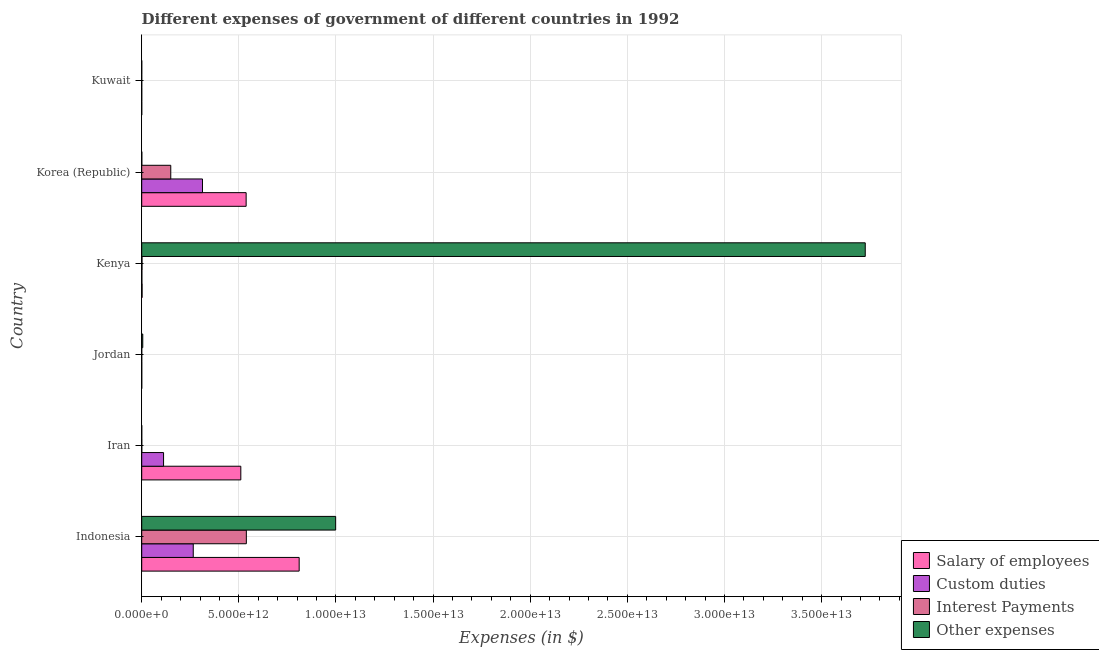How many groups of bars are there?
Provide a short and direct response. 6. Are the number of bars on each tick of the Y-axis equal?
Your answer should be very brief. Yes. How many bars are there on the 5th tick from the top?
Your answer should be very brief. 4. How many bars are there on the 5th tick from the bottom?
Your response must be concise. 4. What is the label of the 1st group of bars from the top?
Ensure brevity in your answer.  Kuwait. What is the amount spent on other expenses in Korea (Republic)?
Your response must be concise. 4.71e+09. Across all countries, what is the maximum amount spent on custom duties?
Ensure brevity in your answer.  3.13e+12. Across all countries, what is the minimum amount spent on interest payments?
Provide a short and direct response. 5.83e+07. In which country was the amount spent on interest payments maximum?
Keep it short and to the point. Indonesia. In which country was the amount spent on other expenses minimum?
Give a very brief answer. Kuwait. What is the total amount spent on interest payments in the graph?
Offer a terse response. 6.90e+12. What is the difference between the amount spent on other expenses in Jordan and that in Kenya?
Keep it short and to the point. -3.72e+13. What is the difference between the amount spent on interest payments in Kenya and the amount spent on salary of employees in Kuwait?
Provide a short and direct response. 1.41e+1. What is the average amount spent on custom duties per country?
Provide a short and direct response. 1.15e+12. What is the difference between the amount spent on interest payments and amount spent on other expenses in Kuwait?
Offer a very short reply. -6.51e+08. What is the ratio of the amount spent on salary of employees in Jordan to that in Kenya?
Keep it short and to the point. 0.03. Is the amount spent on salary of employees in Iran less than that in Kuwait?
Offer a terse response. No. Is the difference between the amount spent on interest payments in Iran and Kenya greater than the difference between the amount spent on salary of employees in Iran and Kenya?
Provide a short and direct response. No. What is the difference between the highest and the second highest amount spent on custom duties?
Ensure brevity in your answer.  4.76e+11. What is the difference between the highest and the lowest amount spent on interest payments?
Ensure brevity in your answer.  5.39e+12. In how many countries, is the amount spent on other expenses greater than the average amount spent on other expenses taken over all countries?
Offer a very short reply. 2. Is the sum of the amount spent on interest payments in Iran and Kenya greater than the maximum amount spent on custom duties across all countries?
Make the answer very short. No. What does the 1st bar from the top in Iran represents?
Offer a very short reply. Other expenses. What does the 3rd bar from the bottom in Jordan represents?
Keep it short and to the point. Interest Payments. Is it the case that in every country, the sum of the amount spent on salary of employees and amount spent on custom duties is greater than the amount spent on interest payments?
Ensure brevity in your answer.  Yes. How many bars are there?
Your answer should be very brief. 24. How many countries are there in the graph?
Provide a short and direct response. 6. What is the difference between two consecutive major ticks on the X-axis?
Your answer should be very brief. 5.00e+12. Are the values on the major ticks of X-axis written in scientific E-notation?
Keep it short and to the point. Yes. Does the graph contain grids?
Make the answer very short. Yes. How many legend labels are there?
Offer a terse response. 4. What is the title of the graph?
Offer a very short reply. Different expenses of government of different countries in 1992. Does "Luxembourg" appear as one of the legend labels in the graph?
Offer a very short reply. No. What is the label or title of the X-axis?
Provide a succinct answer. Expenses (in $). What is the label or title of the Y-axis?
Your answer should be very brief. Country. What is the Expenses (in $) of Salary of employees in Indonesia?
Offer a very short reply. 8.10e+12. What is the Expenses (in $) of Custom duties in Indonesia?
Offer a terse response. 2.65e+12. What is the Expenses (in $) in Interest Payments in Indonesia?
Make the answer very short. 5.39e+12. What is the Expenses (in $) in Other expenses in Indonesia?
Provide a succinct answer. 9.98e+12. What is the Expenses (in $) in Salary of employees in Iran?
Give a very brief answer. 5.10e+12. What is the Expenses (in $) of Custom duties in Iran?
Ensure brevity in your answer.  1.12e+12. What is the Expenses (in $) in Interest Payments in Iran?
Provide a succinct answer. 3.00e+09. What is the Expenses (in $) of Other expenses in Iran?
Offer a very short reply. 8.91e+08. What is the Expenses (in $) in Salary of employees in Jordan?
Your answer should be compact. 5.57e+08. What is the Expenses (in $) in Custom duties in Jordan?
Make the answer very short. 3.89e+08. What is the Expenses (in $) of Interest Payments in Jordan?
Ensure brevity in your answer.  1.56e+08. What is the Expenses (in $) of Other expenses in Jordan?
Your answer should be very brief. 5.39e+1. What is the Expenses (in $) in Salary of employees in Kenya?
Provide a short and direct response. 1.91e+1. What is the Expenses (in $) of Custom duties in Kenya?
Ensure brevity in your answer.  7.74e+09. What is the Expenses (in $) in Interest Payments in Kenya?
Offer a very short reply. 1.49e+1. What is the Expenses (in $) of Other expenses in Kenya?
Offer a very short reply. 3.72e+13. What is the Expenses (in $) in Salary of employees in Korea (Republic)?
Ensure brevity in your answer.  5.38e+12. What is the Expenses (in $) of Custom duties in Korea (Republic)?
Provide a short and direct response. 3.13e+12. What is the Expenses (in $) of Interest Payments in Korea (Republic)?
Offer a terse response. 1.50e+12. What is the Expenses (in $) of Other expenses in Korea (Republic)?
Keep it short and to the point. 4.71e+09. What is the Expenses (in $) in Salary of employees in Kuwait?
Make the answer very short. 8.70e+08. What is the Expenses (in $) of Custom duties in Kuwait?
Offer a very short reply. 5.48e+08. What is the Expenses (in $) of Interest Payments in Kuwait?
Offer a terse response. 5.83e+07. What is the Expenses (in $) in Other expenses in Kuwait?
Your response must be concise. 7.09e+08. Across all countries, what is the maximum Expenses (in $) of Salary of employees?
Offer a very short reply. 8.10e+12. Across all countries, what is the maximum Expenses (in $) of Custom duties?
Offer a very short reply. 3.13e+12. Across all countries, what is the maximum Expenses (in $) of Interest Payments?
Provide a short and direct response. 5.39e+12. Across all countries, what is the maximum Expenses (in $) of Other expenses?
Provide a succinct answer. 3.72e+13. Across all countries, what is the minimum Expenses (in $) in Salary of employees?
Offer a terse response. 5.57e+08. Across all countries, what is the minimum Expenses (in $) of Custom duties?
Give a very brief answer. 3.89e+08. Across all countries, what is the minimum Expenses (in $) of Interest Payments?
Your answer should be compact. 5.83e+07. Across all countries, what is the minimum Expenses (in $) in Other expenses?
Keep it short and to the point. 7.09e+08. What is the total Expenses (in $) of Salary of employees in the graph?
Offer a very short reply. 1.86e+13. What is the total Expenses (in $) in Custom duties in the graph?
Make the answer very short. 6.91e+12. What is the total Expenses (in $) in Interest Payments in the graph?
Your response must be concise. 6.90e+12. What is the total Expenses (in $) in Other expenses in the graph?
Provide a succinct answer. 4.73e+13. What is the difference between the Expenses (in $) in Salary of employees in Indonesia and that in Iran?
Make the answer very short. 3.00e+12. What is the difference between the Expenses (in $) in Custom duties in Indonesia and that in Iran?
Give a very brief answer. 1.53e+12. What is the difference between the Expenses (in $) of Interest Payments in Indonesia and that in Iran?
Give a very brief answer. 5.38e+12. What is the difference between the Expenses (in $) of Other expenses in Indonesia and that in Iran?
Offer a terse response. 9.98e+12. What is the difference between the Expenses (in $) in Salary of employees in Indonesia and that in Jordan?
Make the answer very short. 8.10e+12. What is the difference between the Expenses (in $) in Custom duties in Indonesia and that in Jordan?
Your response must be concise. 2.65e+12. What is the difference between the Expenses (in $) of Interest Payments in Indonesia and that in Jordan?
Provide a short and direct response. 5.39e+12. What is the difference between the Expenses (in $) of Other expenses in Indonesia and that in Jordan?
Your answer should be very brief. 9.93e+12. What is the difference between the Expenses (in $) in Salary of employees in Indonesia and that in Kenya?
Your response must be concise. 8.09e+12. What is the difference between the Expenses (in $) in Custom duties in Indonesia and that in Kenya?
Give a very brief answer. 2.64e+12. What is the difference between the Expenses (in $) in Interest Payments in Indonesia and that in Kenya?
Provide a succinct answer. 5.37e+12. What is the difference between the Expenses (in $) in Other expenses in Indonesia and that in Kenya?
Provide a succinct answer. -2.73e+13. What is the difference between the Expenses (in $) of Salary of employees in Indonesia and that in Korea (Republic)?
Give a very brief answer. 2.73e+12. What is the difference between the Expenses (in $) of Custom duties in Indonesia and that in Korea (Republic)?
Offer a terse response. -4.76e+11. What is the difference between the Expenses (in $) in Interest Payments in Indonesia and that in Korea (Republic)?
Provide a succinct answer. 3.89e+12. What is the difference between the Expenses (in $) of Other expenses in Indonesia and that in Korea (Republic)?
Provide a succinct answer. 9.98e+12. What is the difference between the Expenses (in $) in Salary of employees in Indonesia and that in Kuwait?
Offer a terse response. 8.10e+12. What is the difference between the Expenses (in $) in Custom duties in Indonesia and that in Kuwait?
Offer a terse response. 2.65e+12. What is the difference between the Expenses (in $) in Interest Payments in Indonesia and that in Kuwait?
Offer a terse response. 5.39e+12. What is the difference between the Expenses (in $) in Other expenses in Indonesia and that in Kuwait?
Your answer should be very brief. 9.98e+12. What is the difference between the Expenses (in $) in Salary of employees in Iran and that in Jordan?
Your answer should be compact. 5.10e+12. What is the difference between the Expenses (in $) in Custom duties in Iran and that in Jordan?
Offer a terse response. 1.12e+12. What is the difference between the Expenses (in $) in Interest Payments in Iran and that in Jordan?
Provide a short and direct response. 2.84e+09. What is the difference between the Expenses (in $) in Other expenses in Iran and that in Jordan?
Offer a terse response. -5.30e+1. What is the difference between the Expenses (in $) of Salary of employees in Iran and that in Kenya?
Your response must be concise. 5.08e+12. What is the difference between the Expenses (in $) of Custom duties in Iran and that in Kenya?
Give a very brief answer. 1.12e+12. What is the difference between the Expenses (in $) in Interest Payments in Iran and that in Kenya?
Make the answer very short. -1.19e+1. What is the difference between the Expenses (in $) in Other expenses in Iran and that in Kenya?
Provide a succinct answer. -3.72e+13. What is the difference between the Expenses (in $) in Salary of employees in Iran and that in Korea (Republic)?
Give a very brief answer. -2.74e+11. What is the difference between the Expenses (in $) of Custom duties in Iran and that in Korea (Republic)?
Your answer should be compact. -2.00e+12. What is the difference between the Expenses (in $) in Interest Payments in Iran and that in Korea (Republic)?
Ensure brevity in your answer.  -1.49e+12. What is the difference between the Expenses (in $) of Other expenses in Iran and that in Korea (Republic)?
Ensure brevity in your answer.  -3.82e+09. What is the difference between the Expenses (in $) in Salary of employees in Iran and that in Kuwait?
Ensure brevity in your answer.  5.10e+12. What is the difference between the Expenses (in $) of Custom duties in Iran and that in Kuwait?
Make the answer very short. 1.12e+12. What is the difference between the Expenses (in $) in Interest Payments in Iran and that in Kuwait?
Keep it short and to the point. 2.94e+09. What is the difference between the Expenses (in $) in Other expenses in Iran and that in Kuwait?
Provide a short and direct response. 1.82e+08. What is the difference between the Expenses (in $) in Salary of employees in Jordan and that in Kenya?
Make the answer very short. -1.86e+1. What is the difference between the Expenses (in $) of Custom duties in Jordan and that in Kenya?
Ensure brevity in your answer.  -7.35e+09. What is the difference between the Expenses (in $) in Interest Payments in Jordan and that in Kenya?
Provide a succinct answer. -1.48e+1. What is the difference between the Expenses (in $) in Other expenses in Jordan and that in Kenya?
Make the answer very short. -3.72e+13. What is the difference between the Expenses (in $) in Salary of employees in Jordan and that in Korea (Republic)?
Ensure brevity in your answer.  -5.37e+12. What is the difference between the Expenses (in $) in Custom duties in Jordan and that in Korea (Republic)?
Your answer should be very brief. -3.13e+12. What is the difference between the Expenses (in $) of Interest Payments in Jordan and that in Korea (Republic)?
Your response must be concise. -1.49e+12. What is the difference between the Expenses (in $) of Other expenses in Jordan and that in Korea (Republic)?
Provide a short and direct response. 4.92e+1. What is the difference between the Expenses (in $) in Salary of employees in Jordan and that in Kuwait?
Your answer should be compact. -3.13e+08. What is the difference between the Expenses (in $) of Custom duties in Jordan and that in Kuwait?
Offer a terse response. -1.59e+08. What is the difference between the Expenses (in $) of Interest Payments in Jordan and that in Kuwait?
Give a very brief answer. 9.75e+07. What is the difference between the Expenses (in $) of Other expenses in Jordan and that in Kuwait?
Your answer should be very brief. 5.32e+1. What is the difference between the Expenses (in $) in Salary of employees in Kenya and that in Korea (Republic)?
Your response must be concise. -5.36e+12. What is the difference between the Expenses (in $) of Custom duties in Kenya and that in Korea (Republic)?
Keep it short and to the point. -3.12e+12. What is the difference between the Expenses (in $) of Interest Payments in Kenya and that in Korea (Republic)?
Ensure brevity in your answer.  -1.48e+12. What is the difference between the Expenses (in $) of Other expenses in Kenya and that in Korea (Republic)?
Your answer should be compact. 3.72e+13. What is the difference between the Expenses (in $) of Salary of employees in Kenya and that in Kuwait?
Provide a succinct answer. 1.82e+1. What is the difference between the Expenses (in $) in Custom duties in Kenya and that in Kuwait?
Ensure brevity in your answer.  7.19e+09. What is the difference between the Expenses (in $) in Interest Payments in Kenya and that in Kuwait?
Ensure brevity in your answer.  1.49e+1. What is the difference between the Expenses (in $) in Other expenses in Kenya and that in Kuwait?
Provide a succinct answer. 3.72e+13. What is the difference between the Expenses (in $) of Salary of employees in Korea (Republic) and that in Kuwait?
Your answer should be very brief. 5.37e+12. What is the difference between the Expenses (in $) of Custom duties in Korea (Republic) and that in Kuwait?
Offer a very short reply. 3.13e+12. What is the difference between the Expenses (in $) in Interest Payments in Korea (Republic) and that in Kuwait?
Keep it short and to the point. 1.49e+12. What is the difference between the Expenses (in $) of Other expenses in Korea (Republic) and that in Kuwait?
Ensure brevity in your answer.  4.00e+09. What is the difference between the Expenses (in $) of Salary of employees in Indonesia and the Expenses (in $) of Custom duties in Iran?
Ensure brevity in your answer.  6.98e+12. What is the difference between the Expenses (in $) in Salary of employees in Indonesia and the Expenses (in $) in Interest Payments in Iran?
Your answer should be very brief. 8.10e+12. What is the difference between the Expenses (in $) of Salary of employees in Indonesia and the Expenses (in $) of Other expenses in Iran?
Give a very brief answer. 8.10e+12. What is the difference between the Expenses (in $) of Custom duties in Indonesia and the Expenses (in $) of Interest Payments in Iran?
Your answer should be compact. 2.65e+12. What is the difference between the Expenses (in $) in Custom duties in Indonesia and the Expenses (in $) in Other expenses in Iran?
Your answer should be very brief. 2.65e+12. What is the difference between the Expenses (in $) of Interest Payments in Indonesia and the Expenses (in $) of Other expenses in Iran?
Keep it short and to the point. 5.38e+12. What is the difference between the Expenses (in $) in Salary of employees in Indonesia and the Expenses (in $) in Custom duties in Jordan?
Ensure brevity in your answer.  8.10e+12. What is the difference between the Expenses (in $) in Salary of employees in Indonesia and the Expenses (in $) in Interest Payments in Jordan?
Give a very brief answer. 8.10e+12. What is the difference between the Expenses (in $) of Salary of employees in Indonesia and the Expenses (in $) of Other expenses in Jordan?
Keep it short and to the point. 8.05e+12. What is the difference between the Expenses (in $) in Custom duties in Indonesia and the Expenses (in $) in Interest Payments in Jordan?
Keep it short and to the point. 2.65e+12. What is the difference between the Expenses (in $) in Custom duties in Indonesia and the Expenses (in $) in Other expenses in Jordan?
Make the answer very short. 2.60e+12. What is the difference between the Expenses (in $) in Interest Payments in Indonesia and the Expenses (in $) in Other expenses in Jordan?
Keep it short and to the point. 5.33e+12. What is the difference between the Expenses (in $) of Salary of employees in Indonesia and the Expenses (in $) of Custom duties in Kenya?
Your response must be concise. 8.10e+12. What is the difference between the Expenses (in $) of Salary of employees in Indonesia and the Expenses (in $) of Interest Payments in Kenya?
Keep it short and to the point. 8.09e+12. What is the difference between the Expenses (in $) in Salary of employees in Indonesia and the Expenses (in $) in Other expenses in Kenya?
Give a very brief answer. -2.91e+13. What is the difference between the Expenses (in $) of Custom duties in Indonesia and the Expenses (in $) of Interest Payments in Kenya?
Your answer should be compact. 2.64e+12. What is the difference between the Expenses (in $) of Custom duties in Indonesia and the Expenses (in $) of Other expenses in Kenya?
Give a very brief answer. -3.46e+13. What is the difference between the Expenses (in $) in Interest Payments in Indonesia and the Expenses (in $) in Other expenses in Kenya?
Keep it short and to the point. -3.19e+13. What is the difference between the Expenses (in $) in Salary of employees in Indonesia and the Expenses (in $) in Custom duties in Korea (Republic)?
Your response must be concise. 4.98e+12. What is the difference between the Expenses (in $) of Salary of employees in Indonesia and the Expenses (in $) of Interest Payments in Korea (Republic)?
Make the answer very short. 6.61e+12. What is the difference between the Expenses (in $) of Salary of employees in Indonesia and the Expenses (in $) of Other expenses in Korea (Republic)?
Give a very brief answer. 8.10e+12. What is the difference between the Expenses (in $) in Custom duties in Indonesia and the Expenses (in $) in Interest Payments in Korea (Republic)?
Your answer should be very brief. 1.16e+12. What is the difference between the Expenses (in $) of Custom duties in Indonesia and the Expenses (in $) of Other expenses in Korea (Republic)?
Give a very brief answer. 2.65e+12. What is the difference between the Expenses (in $) in Interest Payments in Indonesia and the Expenses (in $) in Other expenses in Korea (Republic)?
Offer a very short reply. 5.38e+12. What is the difference between the Expenses (in $) of Salary of employees in Indonesia and the Expenses (in $) of Custom duties in Kuwait?
Give a very brief answer. 8.10e+12. What is the difference between the Expenses (in $) in Salary of employees in Indonesia and the Expenses (in $) in Interest Payments in Kuwait?
Offer a very short reply. 8.10e+12. What is the difference between the Expenses (in $) in Salary of employees in Indonesia and the Expenses (in $) in Other expenses in Kuwait?
Your answer should be very brief. 8.10e+12. What is the difference between the Expenses (in $) of Custom duties in Indonesia and the Expenses (in $) of Interest Payments in Kuwait?
Keep it short and to the point. 2.65e+12. What is the difference between the Expenses (in $) of Custom duties in Indonesia and the Expenses (in $) of Other expenses in Kuwait?
Ensure brevity in your answer.  2.65e+12. What is the difference between the Expenses (in $) in Interest Payments in Indonesia and the Expenses (in $) in Other expenses in Kuwait?
Your response must be concise. 5.38e+12. What is the difference between the Expenses (in $) in Salary of employees in Iran and the Expenses (in $) in Custom duties in Jordan?
Provide a succinct answer. 5.10e+12. What is the difference between the Expenses (in $) of Salary of employees in Iran and the Expenses (in $) of Interest Payments in Jordan?
Make the answer very short. 5.10e+12. What is the difference between the Expenses (in $) of Salary of employees in Iran and the Expenses (in $) of Other expenses in Jordan?
Your response must be concise. 5.05e+12. What is the difference between the Expenses (in $) of Custom duties in Iran and the Expenses (in $) of Interest Payments in Jordan?
Give a very brief answer. 1.12e+12. What is the difference between the Expenses (in $) in Custom duties in Iran and the Expenses (in $) in Other expenses in Jordan?
Give a very brief answer. 1.07e+12. What is the difference between the Expenses (in $) of Interest Payments in Iran and the Expenses (in $) of Other expenses in Jordan?
Provide a short and direct response. -5.09e+1. What is the difference between the Expenses (in $) in Salary of employees in Iran and the Expenses (in $) in Custom duties in Kenya?
Make the answer very short. 5.09e+12. What is the difference between the Expenses (in $) in Salary of employees in Iran and the Expenses (in $) in Interest Payments in Kenya?
Ensure brevity in your answer.  5.09e+12. What is the difference between the Expenses (in $) in Salary of employees in Iran and the Expenses (in $) in Other expenses in Kenya?
Your answer should be compact. -3.21e+13. What is the difference between the Expenses (in $) in Custom duties in Iran and the Expenses (in $) in Interest Payments in Kenya?
Your answer should be compact. 1.11e+12. What is the difference between the Expenses (in $) in Custom duties in Iran and the Expenses (in $) in Other expenses in Kenya?
Your response must be concise. -3.61e+13. What is the difference between the Expenses (in $) of Interest Payments in Iran and the Expenses (in $) of Other expenses in Kenya?
Offer a terse response. -3.72e+13. What is the difference between the Expenses (in $) in Salary of employees in Iran and the Expenses (in $) in Custom duties in Korea (Republic)?
Provide a succinct answer. 1.97e+12. What is the difference between the Expenses (in $) of Salary of employees in Iran and the Expenses (in $) of Interest Payments in Korea (Republic)?
Offer a terse response. 3.61e+12. What is the difference between the Expenses (in $) of Salary of employees in Iran and the Expenses (in $) of Other expenses in Korea (Republic)?
Provide a succinct answer. 5.10e+12. What is the difference between the Expenses (in $) in Custom duties in Iran and the Expenses (in $) in Interest Payments in Korea (Republic)?
Your response must be concise. -3.70e+11. What is the difference between the Expenses (in $) in Custom duties in Iran and the Expenses (in $) in Other expenses in Korea (Republic)?
Make the answer very short. 1.12e+12. What is the difference between the Expenses (in $) of Interest Payments in Iran and the Expenses (in $) of Other expenses in Korea (Republic)?
Your answer should be compact. -1.71e+09. What is the difference between the Expenses (in $) of Salary of employees in Iran and the Expenses (in $) of Custom duties in Kuwait?
Give a very brief answer. 5.10e+12. What is the difference between the Expenses (in $) of Salary of employees in Iran and the Expenses (in $) of Interest Payments in Kuwait?
Your answer should be compact. 5.10e+12. What is the difference between the Expenses (in $) in Salary of employees in Iran and the Expenses (in $) in Other expenses in Kuwait?
Your answer should be very brief. 5.10e+12. What is the difference between the Expenses (in $) in Custom duties in Iran and the Expenses (in $) in Interest Payments in Kuwait?
Make the answer very short. 1.12e+12. What is the difference between the Expenses (in $) in Custom duties in Iran and the Expenses (in $) in Other expenses in Kuwait?
Your response must be concise. 1.12e+12. What is the difference between the Expenses (in $) of Interest Payments in Iran and the Expenses (in $) of Other expenses in Kuwait?
Give a very brief answer. 2.29e+09. What is the difference between the Expenses (in $) in Salary of employees in Jordan and the Expenses (in $) in Custom duties in Kenya?
Give a very brief answer. -7.18e+09. What is the difference between the Expenses (in $) in Salary of employees in Jordan and the Expenses (in $) in Interest Payments in Kenya?
Provide a short and direct response. -1.44e+1. What is the difference between the Expenses (in $) in Salary of employees in Jordan and the Expenses (in $) in Other expenses in Kenya?
Offer a very short reply. -3.72e+13. What is the difference between the Expenses (in $) of Custom duties in Jordan and the Expenses (in $) of Interest Payments in Kenya?
Offer a very short reply. -1.45e+1. What is the difference between the Expenses (in $) in Custom duties in Jordan and the Expenses (in $) in Other expenses in Kenya?
Offer a very short reply. -3.72e+13. What is the difference between the Expenses (in $) in Interest Payments in Jordan and the Expenses (in $) in Other expenses in Kenya?
Offer a very short reply. -3.72e+13. What is the difference between the Expenses (in $) in Salary of employees in Jordan and the Expenses (in $) in Custom duties in Korea (Republic)?
Your answer should be compact. -3.13e+12. What is the difference between the Expenses (in $) of Salary of employees in Jordan and the Expenses (in $) of Interest Payments in Korea (Republic)?
Keep it short and to the point. -1.49e+12. What is the difference between the Expenses (in $) in Salary of employees in Jordan and the Expenses (in $) in Other expenses in Korea (Republic)?
Your answer should be very brief. -4.15e+09. What is the difference between the Expenses (in $) in Custom duties in Jordan and the Expenses (in $) in Interest Payments in Korea (Republic)?
Ensure brevity in your answer.  -1.49e+12. What is the difference between the Expenses (in $) in Custom duties in Jordan and the Expenses (in $) in Other expenses in Korea (Republic)?
Provide a short and direct response. -4.32e+09. What is the difference between the Expenses (in $) in Interest Payments in Jordan and the Expenses (in $) in Other expenses in Korea (Republic)?
Your answer should be very brief. -4.56e+09. What is the difference between the Expenses (in $) in Salary of employees in Jordan and the Expenses (in $) in Custom duties in Kuwait?
Ensure brevity in your answer.  9.28e+06. What is the difference between the Expenses (in $) of Salary of employees in Jordan and the Expenses (in $) of Interest Payments in Kuwait?
Keep it short and to the point. 4.99e+08. What is the difference between the Expenses (in $) of Salary of employees in Jordan and the Expenses (in $) of Other expenses in Kuwait?
Keep it short and to the point. -1.52e+08. What is the difference between the Expenses (in $) in Custom duties in Jordan and the Expenses (in $) in Interest Payments in Kuwait?
Your response must be concise. 3.31e+08. What is the difference between the Expenses (in $) in Custom duties in Jordan and the Expenses (in $) in Other expenses in Kuwait?
Make the answer very short. -3.20e+08. What is the difference between the Expenses (in $) in Interest Payments in Jordan and the Expenses (in $) in Other expenses in Kuwait?
Offer a terse response. -5.54e+08. What is the difference between the Expenses (in $) in Salary of employees in Kenya and the Expenses (in $) in Custom duties in Korea (Republic)?
Offer a terse response. -3.11e+12. What is the difference between the Expenses (in $) of Salary of employees in Kenya and the Expenses (in $) of Interest Payments in Korea (Republic)?
Your response must be concise. -1.48e+12. What is the difference between the Expenses (in $) in Salary of employees in Kenya and the Expenses (in $) in Other expenses in Korea (Republic)?
Give a very brief answer. 1.44e+1. What is the difference between the Expenses (in $) in Custom duties in Kenya and the Expenses (in $) in Interest Payments in Korea (Republic)?
Provide a short and direct response. -1.49e+12. What is the difference between the Expenses (in $) in Custom duties in Kenya and the Expenses (in $) in Other expenses in Korea (Republic)?
Offer a very short reply. 3.03e+09. What is the difference between the Expenses (in $) of Interest Payments in Kenya and the Expenses (in $) of Other expenses in Korea (Republic)?
Give a very brief answer. 1.02e+1. What is the difference between the Expenses (in $) in Salary of employees in Kenya and the Expenses (in $) in Custom duties in Kuwait?
Your answer should be very brief. 1.86e+1. What is the difference between the Expenses (in $) in Salary of employees in Kenya and the Expenses (in $) in Interest Payments in Kuwait?
Make the answer very short. 1.91e+1. What is the difference between the Expenses (in $) in Salary of employees in Kenya and the Expenses (in $) in Other expenses in Kuwait?
Give a very brief answer. 1.84e+1. What is the difference between the Expenses (in $) in Custom duties in Kenya and the Expenses (in $) in Interest Payments in Kuwait?
Your answer should be compact. 7.68e+09. What is the difference between the Expenses (in $) of Custom duties in Kenya and the Expenses (in $) of Other expenses in Kuwait?
Offer a terse response. 7.03e+09. What is the difference between the Expenses (in $) of Interest Payments in Kenya and the Expenses (in $) of Other expenses in Kuwait?
Make the answer very short. 1.42e+1. What is the difference between the Expenses (in $) of Salary of employees in Korea (Republic) and the Expenses (in $) of Custom duties in Kuwait?
Your answer should be very brief. 5.37e+12. What is the difference between the Expenses (in $) in Salary of employees in Korea (Republic) and the Expenses (in $) in Interest Payments in Kuwait?
Keep it short and to the point. 5.37e+12. What is the difference between the Expenses (in $) in Salary of employees in Korea (Republic) and the Expenses (in $) in Other expenses in Kuwait?
Ensure brevity in your answer.  5.37e+12. What is the difference between the Expenses (in $) of Custom duties in Korea (Republic) and the Expenses (in $) of Interest Payments in Kuwait?
Provide a succinct answer. 3.13e+12. What is the difference between the Expenses (in $) of Custom duties in Korea (Republic) and the Expenses (in $) of Other expenses in Kuwait?
Keep it short and to the point. 3.13e+12. What is the difference between the Expenses (in $) of Interest Payments in Korea (Republic) and the Expenses (in $) of Other expenses in Kuwait?
Ensure brevity in your answer.  1.49e+12. What is the average Expenses (in $) of Salary of employees per country?
Offer a terse response. 3.10e+12. What is the average Expenses (in $) in Custom duties per country?
Offer a terse response. 1.15e+12. What is the average Expenses (in $) of Interest Payments per country?
Keep it short and to the point. 1.15e+12. What is the average Expenses (in $) of Other expenses per country?
Ensure brevity in your answer.  7.88e+12. What is the difference between the Expenses (in $) of Salary of employees and Expenses (in $) of Custom duties in Indonesia?
Offer a terse response. 5.45e+12. What is the difference between the Expenses (in $) in Salary of employees and Expenses (in $) in Interest Payments in Indonesia?
Provide a succinct answer. 2.72e+12. What is the difference between the Expenses (in $) in Salary of employees and Expenses (in $) in Other expenses in Indonesia?
Offer a terse response. -1.88e+12. What is the difference between the Expenses (in $) in Custom duties and Expenses (in $) in Interest Payments in Indonesia?
Offer a very short reply. -2.73e+12. What is the difference between the Expenses (in $) of Custom duties and Expenses (in $) of Other expenses in Indonesia?
Provide a short and direct response. -7.33e+12. What is the difference between the Expenses (in $) in Interest Payments and Expenses (in $) in Other expenses in Indonesia?
Provide a succinct answer. -4.60e+12. What is the difference between the Expenses (in $) in Salary of employees and Expenses (in $) in Custom duties in Iran?
Provide a succinct answer. 3.98e+12. What is the difference between the Expenses (in $) of Salary of employees and Expenses (in $) of Interest Payments in Iran?
Provide a succinct answer. 5.10e+12. What is the difference between the Expenses (in $) of Salary of employees and Expenses (in $) of Other expenses in Iran?
Offer a very short reply. 5.10e+12. What is the difference between the Expenses (in $) of Custom duties and Expenses (in $) of Interest Payments in Iran?
Your answer should be compact. 1.12e+12. What is the difference between the Expenses (in $) of Custom duties and Expenses (in $) of Other expenses in Iran?
Ensure brevity in your answer.  1.12e+12. What is the difference between the Expenses (in $) in Interest Payments and Expenses (in $) in Other expenses in Iran?
Offer a very short reply. 2.11e+09. What is the difference between the Expenses (in $) of Salary of employees and Expenses (in $) of Custom duties in Jordan?
Offer a terse response. 1.68e+08. What is the difference between the Expenses (in $) in Salary of employees and Expenses (in $) in Interest Payments in Jordan?
Your answer should be compact. 4.01e+08. What is the difference between the Expenses (in $) of Salary of employees and Expenses (in $) of Other expenses in Jordan?
Give a very brief answer. -5.34e+1. What is the difference between the Expenses (in $) in Custom duties and Expenses (in $) in Interest Payments in Jordan?
Your answer should be very brief. 2.34e+08. What is the difference between the Expenses (in $) in Custom duties and Expenses (in $) in Other expenses in Jordan?
Your answer should be very brief. -5.35e+1. What is the difference between the Expenses (in $) of Interest Payments and Expenses (in $) of Other expenses in Jordan?
Provide a succinct answer. -5.38e+1. What is the difference between the Expenses (in $) in Salary of employees and Expenses (in $) in Custom duties in Kenya?
Ensure brevity in your answer.  1.14e+1. What is the difference between the Expenses (in $) in Salary of employees and Expenses (in $) in Interest Payments in Kenya?
Provide a succinct answer. 4.20e+09. What is the difference between the Expenses (in $) of Salary of employees and Expenses (in $) of Other expenses in Kenya?
Your response must be concise. -3.72e+13. What is the difference between the Expenses (in $) in Custom duties and Expenses (in $) in Interest Payments in Kenya?
Keep it short and to the point. -7.18e+09. What is the difference between the Expenses (in $) in Custom duties and Expenses (in $) in Other expenses in Kenya?
Your answer should be compact. -3.72e+13. What is the difference between the Expenses (in $) of Interest Payments and Expenses (in $) of Other expenses in Kenya?
Provide a succinct answer. -3.72e+13. What is the difference between the Expenses (in $) of Salary of employees and Expenses (in $) of Custom duties in Korea (Republic)?
Provide a short and direct response. 2.25e+12. What is the difference between the Expenses (in $) of Salary of employees and Expenses (in $) of Interest Payments in Korea (Republic)?
Ensure brevity in your answer.  3.88e+12. What is the difference between the Expenses (in $) of Salary of employees and Expenses (in $) of Other expenses in Korea (Republic)?
Ensure brevity in your answer.  5.37e+12. What is the difference between the Expenses (in $) of Custom duties and Expenses (in $) of Interest Payments in Korea (Republic)?
Your answer should be very brief. 1.63e+12. What is the difference between the Expenses (in $) in Custom duties and Expenses (in $) in Other expenses in Korea (Republic)?
Your answer should be compact. 3.12e+12. What is the difference between the Expenses (in $) in Interest Payments and Expenses (in $) in Other expenses in Korea (Republic)?
Keep it short and to the point. 1.49e+12. What is the difference between the Expenses (in $) in Salary of employees and Expenses (in $) in Custom duties in Kuwait?
Ensure brevity in your answer.  3.22e+08. What is the difference between the Expenses (in $) in Salary of employees and Expenses (in $) in Interest Payments in Kuwait?
Provide a succinct answer. 8.12e+08. What is the difference between the Expenses (in $) of Salary of employees and Expenses (in $) of Other expenses in Kuwait?
Provide a short and direct response. 1.61e+08. What is the difference between the Expenses (in $) of Custom duties and Expenses (in $) of Interest Payments in Kuwait?
Offer a very short reply. 4.90e+08. What is the difference between the Expenses (in $) of Custom duties and Expenses (in $) of Other expenses in Kuwait?
Ensure brevity in your answer.  -1.62e+08. What is the difference between the Expenses (in $) in Interest Payments and Expenses (in $) in Other expenses in Kuwait?
Your answer should be compact. -6.51e+08. What is the ratio of the Expenses (in $) of Salary of employees in Indonesia to that in Iran?
Provide a succinct answer. 1.59. What is the ratio of the Expenses (in $) of Custom duties in Indonesia to that in Iran?
Provide a short and direct response. 2.36. What is the ratio of the Expenses (in $) in Interest Payments in Indonesia to that in Iran?
Keep it short and to the point. 1795.23. What is the ratio of the Expenses (in $) in Other expenses in Indonesia to that in Iran?
Offer a terse response. 1.12e+04. What is the ratio of the Expenses (in $) in Salary of employees in Indonesia to that in Jordan?
Ensure brevity in your answer.  1.45e+04. What is the ratio of the Expenses (in $) in Custom duties in Indonesia to that in Jordan?
Your answer should be very brief. 6812.92. What is the ratio of the Expenses (in $) of Interest Payments in Indonesia to that in Jordan?
Make the answer very short. 3.46e+04. What is the ratio of the Expenses (in $) in Other expenses in Indonesia to that in Jordan?
Offer a very short reply. 185.17. What is the ratio of the Expenses (in $) in Salary of employees in Indonesia to that in Kenya?
Provide a succinct answer. 423.94. What is the ratio of the Expenses (in $) of Custom duties in Indonesia to that in Kenya?
Offer a terse response. 342.75. What is the ratio of the Expenses (in $) of Interest Payments in Indonesia to that in Kenya?
Offer a very short reply. 360.92. What is the ratio of the Expenses (in $) in Other expenses in Indonesia to that in Kenya?
Ensure brevity in your answer.  0.27. What is the ratio of the Expenses (in $) in Salary of employees in Indonesia to that in Korea (Republic)?
Provide a succinct answer. 1.51. What is the ratio of the Expenses (in $) of Custom duties in Indonesia to that in Korea (Republic)?
Offer a terse response. 0.85. What is the ratio of the Expenses (in $) of Interest Payments in Indonesia to that in Korea (Republic)?
Your answer should be very brief. 3.6. What is the ratio of the Expenses (in $) in Other expenses in Indonesia to that in Korea (Republic)?
Give a very brief answer. 2119.08. What is the ratio of the Expenses (in $) of Salary of employees in Indonesia to that in Kuwait?
Offer a terse response. 9315.4. What is the ratio of the Expenses (in $) in Custom duties in Indonesia to that in Kuwait?
Ensure brevity in your answer.  4840.62. What is the ratio of the Expenses (in $) of Interest Payments in Indonesia to that in Kuwait?
Offer a very short reply. 9.24e+04. What is the ratio of the Expenses (in $) of Other expenses in Indonesia to that in Kuwait?
Make the answer very short. 1.41e+04. What is the ratio of the Expenses (in $) in Salary of employees in Iran to that in Jordan?
Give a very brief answer. 9154.87. What is the ratio of the Expenses (in $) in Custom duties in Iran to that in Jordan?
Your answer should be compact. 2888.59. What is the ratio of the Expenses (in $) of Interest Payments in Iran to that in Jordan?
Provide a succinct answer. 19.26. What is the ratio of the Expenses (in $) of Other expenses in Iran to that in Jordan?
Your answer should be compact. 0.02. What is the ratio of the Expenses (in $) of Salary of employees in Iran to that in Kenya?
Keep it short and to the point. 266.83. What is the ratio of the Expenses (in $) in Custom duties in Iran to that in Kenya?
Make the answer very short. 145.32. What is the ratio of the Expenses (in $) of Interest Payments in Iran to that in Kenya?
Give a very brief answer. 0.2. What is the ratio of the Expenses (in $) in Other expenses in Iran to that in Kenya?
Give a very brief answer. 0. What is the ratio of the Expenses (in $) of Salary of employees in Iran to that in Korea (Republic)?
Offer a terse response. 0.95. What is the ratio of the Expenses (in $) of Custom duties in Iran to that in Korea (Republic)?
Offer a very short reply. 0.36. What is the ratio of the Expenses (in $) of Interest Payments in Iran to that in Korea (Republic)?
Provide a succinct answer. 0. What is the ratio of the Expenses (in $) of Other expenses in Iran to that in Korea (Republic)?
Make the answer very short. 0.19. What is the ratio of the Expenses (in $) of Salary of employees in Iran to that in Kuwait?
Offer a terse response. 5863.22. What is the ratio of the Expenses (in $) of Custom duties in Iran to that in Kuwait?
Make the answer very short. 2052.36. What is the ratio of the Expenses (in $) in Interest Payments in Iran to that in Kuwait?
Your response must be concise. 51.46. What is the ratio of the Expenses (in $) in Other expenses in Iran to that in Kuwait?
Ensure brevity in your answer.  1.26. What is the ratio of the Expenses (in $) in Salary of employees in Jordan to that in Kenya?
Provide a succinct answer. 0.03. What is the ratio of the Expenses (in $) in Custom duties in Jordan to that in Kenya?
Your answer should be very brief. 0.05. What is the ratio of the Expenses (in $) of Interest Payments in Jordan to that in Kenya?
Your answer should be very brief. 0.01. What is the ratio of the Expenses (in $) in Other expenses in Jordan to that in Kenya?
Make the answer very short. 0. What is the ratio of the Expenses (in $) of Salary of employees in Jordan to that in Korea (Republic)?
Ensure brevity in your answer.  0. What is the ratio of the Expenses (in $) in Interest Payments in Jordan to that in Korea (Republic)?
Your response must be concise. 0. What is the ratio of the Expenses (in $) of Other expenses in Jordan to that in Korea (Republic)?
Provide a succinct answer. 11.44. What is the ratio of the Expenses (in $) of Salary of employees in Jordan to that in Kuwait?
Your answer should be compact. 0.64. What is the ratio of the Expenses (in $) in Custom duties in Jordan to that in Kuwait?
Your answer should be very brief. 0.71. What is the ratio of the Expenses (in $) in Interest Payments in Jordan to that in Kuwait?
Ensure brevity in your answer.  2.67. What is the ratio of the Expenses (in $) of Other expenses in Jordan to that in Kuwait?
Ensure brevity in your answer.  75.99. What is the ratio of the Expenses (in $) of Salary of employees in Kenya to that in Korea (Republic)?
Keep it short and to the point. 0. What is the ratio of the Expenses (in $) in Custom duties in Kenya to that in Korea (Republic)?
Offer a very short reply. 0. What is the ratio of the Expenses (in $) of Other expenses in Kenya to that in Korea (Republic)?
Provide a short and direct response. 7905.75. What is the ratio of the Expenses (in $) of Salary of employees in Kenya to that in Kuwait?
Offer a very short reply. 21.97. What is the ratio of the Expenses (in $) of Custom duties in Kenya to that in Kuwait?
Give a very brief answer. 14.12. What is the ratio of the Expenses (in $) of Interest Payments in Kenya to that in Kuwait?
Provide a succinct answer. 255.95. What is the ratio of the Expenses (in $) of Other expenses in Kenya to that in Kuwait?
Offer a very short reply. 5.25e+04. What is the ratio of the Expenses (in $) in Salary of employees in Korea (Republic) to that in Kuwait?
Give a very brief answer. 6178.16. What is the ratio of the Expenses (in $) in Custom duties in Korea (Republic) to that in Kuwait?
Offer a very short reply. 5709.02. What is the ratio of the Expenses (in $) of Interest Payments in Korea (Republic) to that in Kuwait?
Provide a short and direct response. 2.56e+04. What is the ratio of the Expenses (in $) of Other expenses in Korea (Republic) to that in Kuwait?
Your answer should be compact. 6.64. What is the difference between the highest and the second highest Expenses (in $) of Salary of employees?
Your answer should be very brief. 2.73e+12. What is the difference between the highest and the second highest Expenses (in $) in Custom duties?
Your answer should be compact. 4.76e+11. What is the difference between the highest and the second highest Expenses (in $) in Interest Payments?
Your answer should be compact. 3.89e+12. What is the difference between the highest and the second highest Expenses (in $) in Other expenses?
Your answer should be very brief. 2.73e+13. What is the difference between the highest and the lowest Expenses (in $) of Salary of employees?
Your answer should be compact. 8.10e+12. What is the difference between the highest and the lowest Expenses (in $) of Custom duties?
Provide a short and direct response. 3.13e+12. What is the difference between the highest and the lowest Expenses (in $) in Interest Payments?
Offer a very short reply. 5.39e+12. What is the difference between the highest and the lowest Expenses (in $) in Other expenses?
Offer a very short reply. 3.72e+13. 